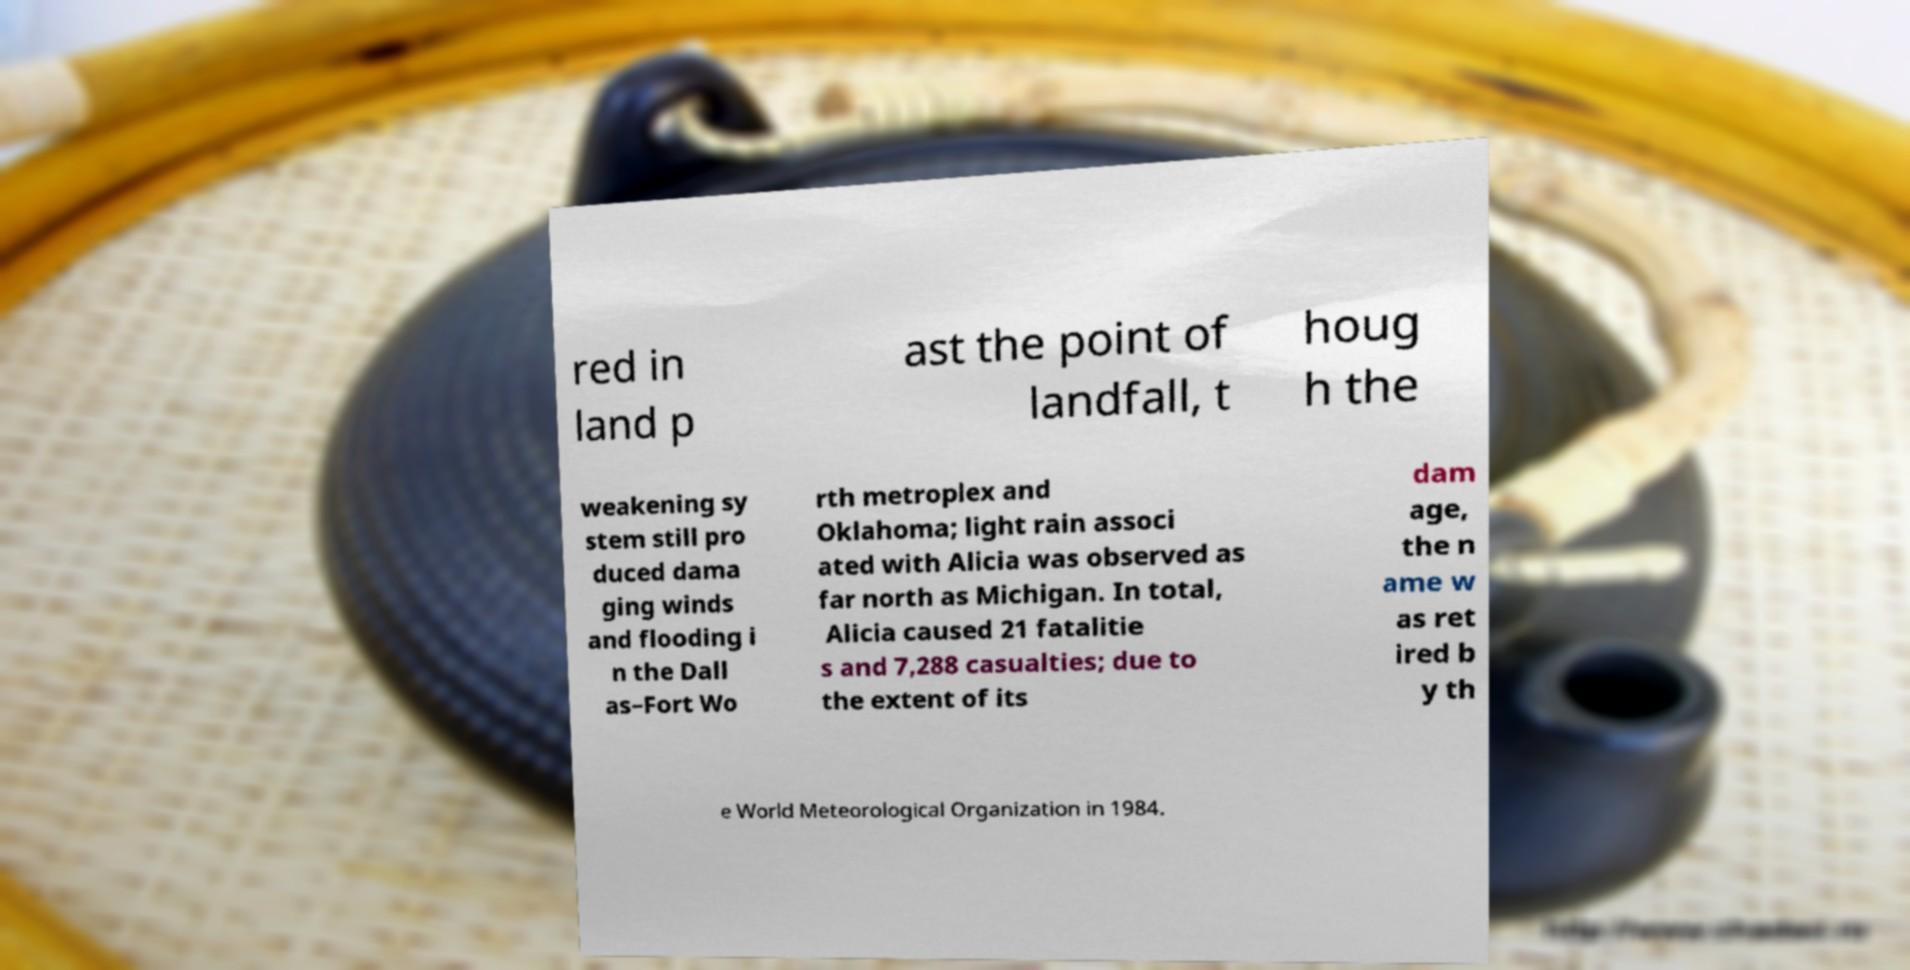Can you accurately transcribe the text from the provided image for me? red in land p ast the point of landfall, t houg h the weakening sy stem still pro duced dama ging winds and flooding i n the Dall as–Fort Wo rth metroplex and Oklahoma; light rain associ ated with Alicia was observed as far north as Michigan. In total, Alicia caused 21 fatalitie s and 7,288 casualties; due to the extent of its dam age, the n ame w as ret ired b y th e World Meteorological Organization in 1984. 